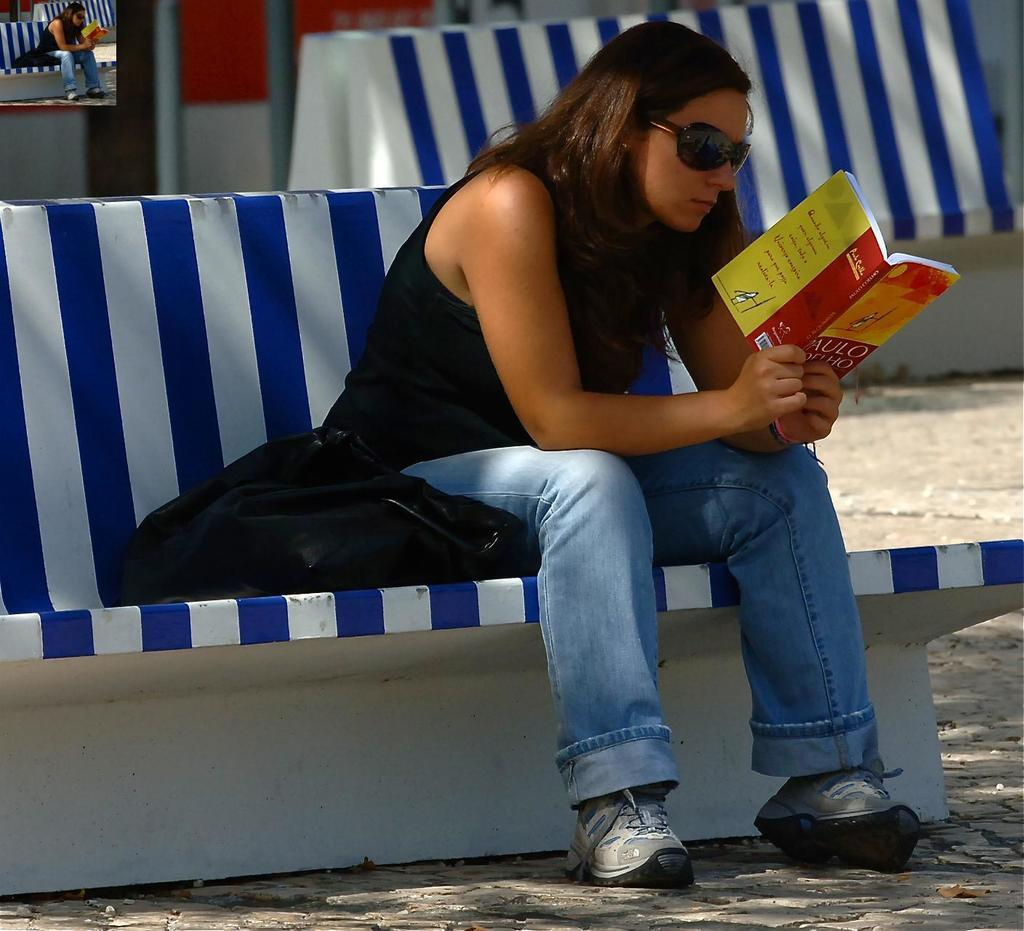<image>
Share a concise interpretation of the image provided. A girl sitting on a blue and white bench hold a book by Paulo in her hand 